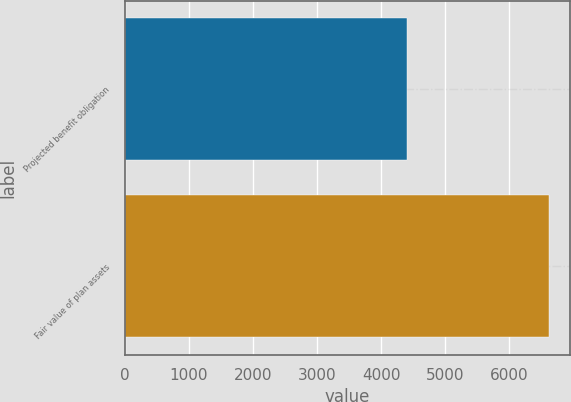Convert chart to OTSL. <chart><loc_0><loc_0><loc_500><loc_500><bar_chart><fcel>Projected benefit obligation<fcel>Fair value of plan assets<nl><fcel>4404<fcel>6616<nl></chart> 